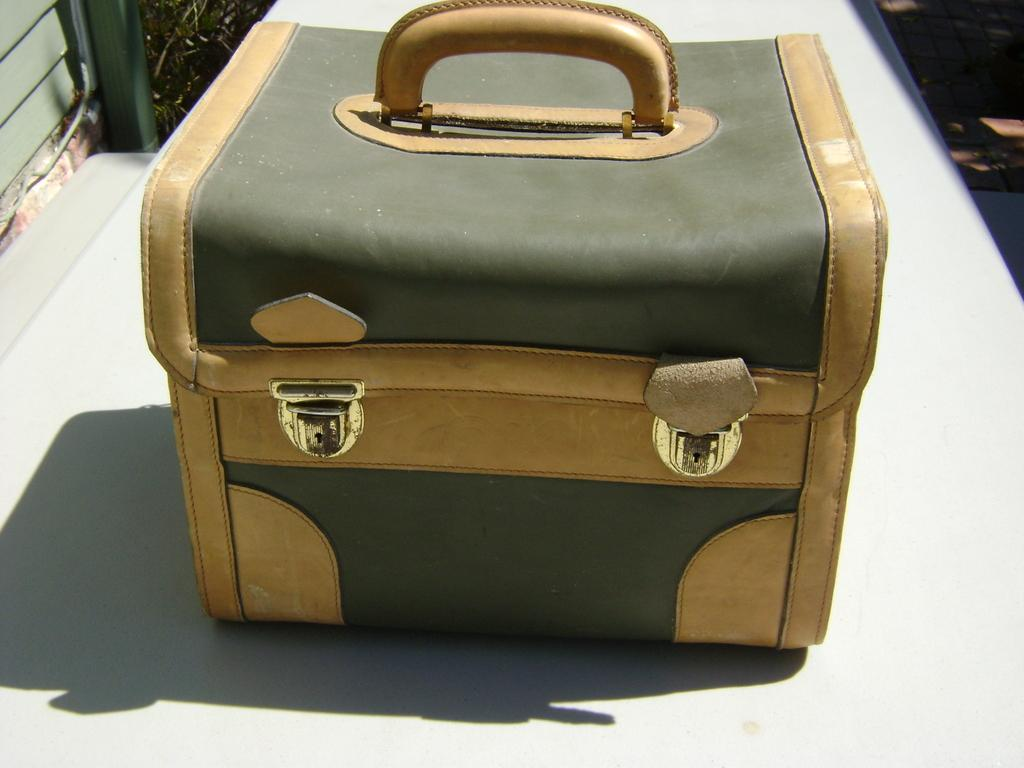What object is present on the floor in the image? There is a bag on the floor in the image. What feature does the bag have to secure its contents? The bag has two clips to secure its contents. How can the bag be carried or held? The bag has a handle for carrying or holding. What is the color of the floor in the image? The floor is white in color. What scientific experiment is being conducted with the bag in the image? There is no scientific experiment being conducted with the bag in the image. Can you see a wristwatch on the bag in the image? There is no wristwatch visible on the bag in the image. 